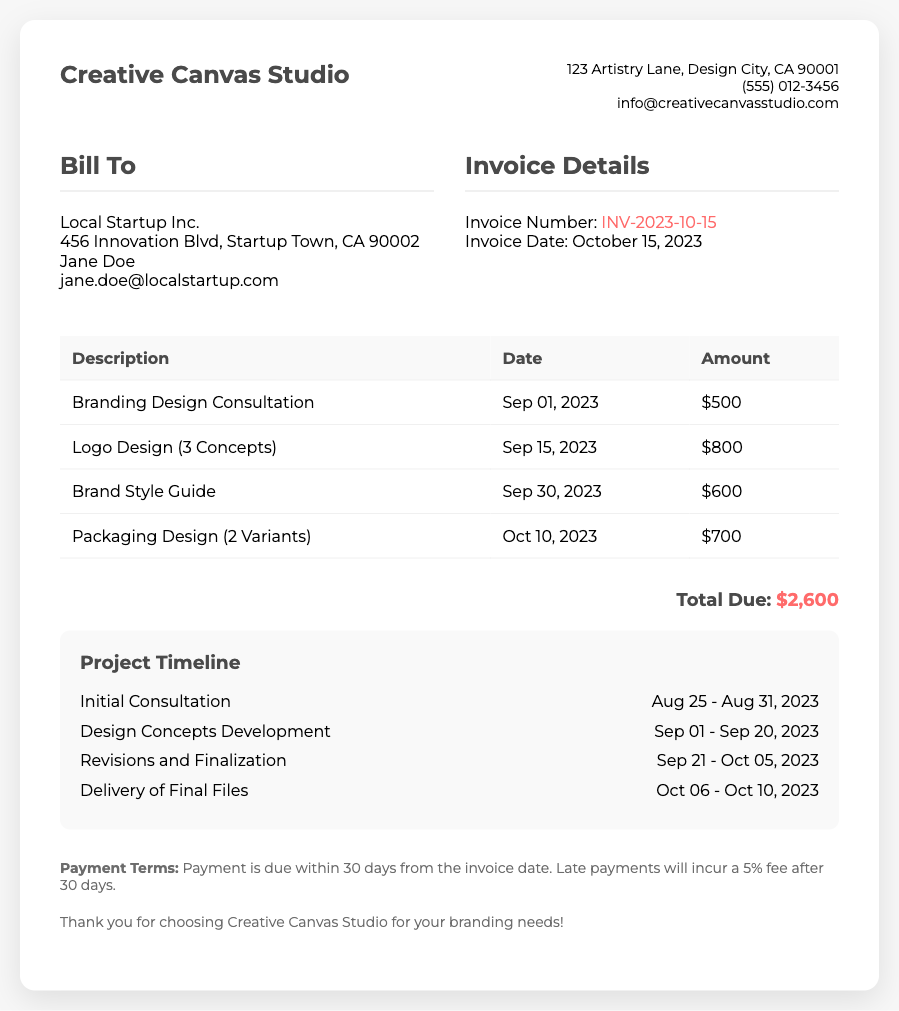What is the total amount due? The total amount due is mentioned in the total section of the invoice, which is $2,600.
Answer: $2,600 Who is the contact at Local Startup Inc.? The contact person at Local Startup Inc. is mentioned in the bill to section, which is Jane Doe.
Answer: Jane Doe What is the invoice date? The invoice date is specified in the invoice details section, which is October 15, 2023.
Answer: October 15, 2023 When was the delivery of final files? The delivery of final files is included in the project timeline, which lists the dates as October 06 to October 10, 2023.
Answer: October 06 - October 10, 2023 What is the payment term? The payment term states that payment is due within 30 days from the invoice date.
Answer: 30 days How many design concepts were provided for the logo design? The logo design section notes that 3 concepts were provided.
Answer: 3 Concepts What is the cost of the packaging design? The cost for the packaging design is listed in the table as $700.
Answer: $700 What phase follows the design concepts development in the project timeline? The phase that follows design concepts development is noted as revisions and finalization.
Answer: Revisions and Finalization What is the service provided on September 1, 2023? The service provided on September 1, 2023, is branding design consultation.
Answer: Branding Design Consultation 